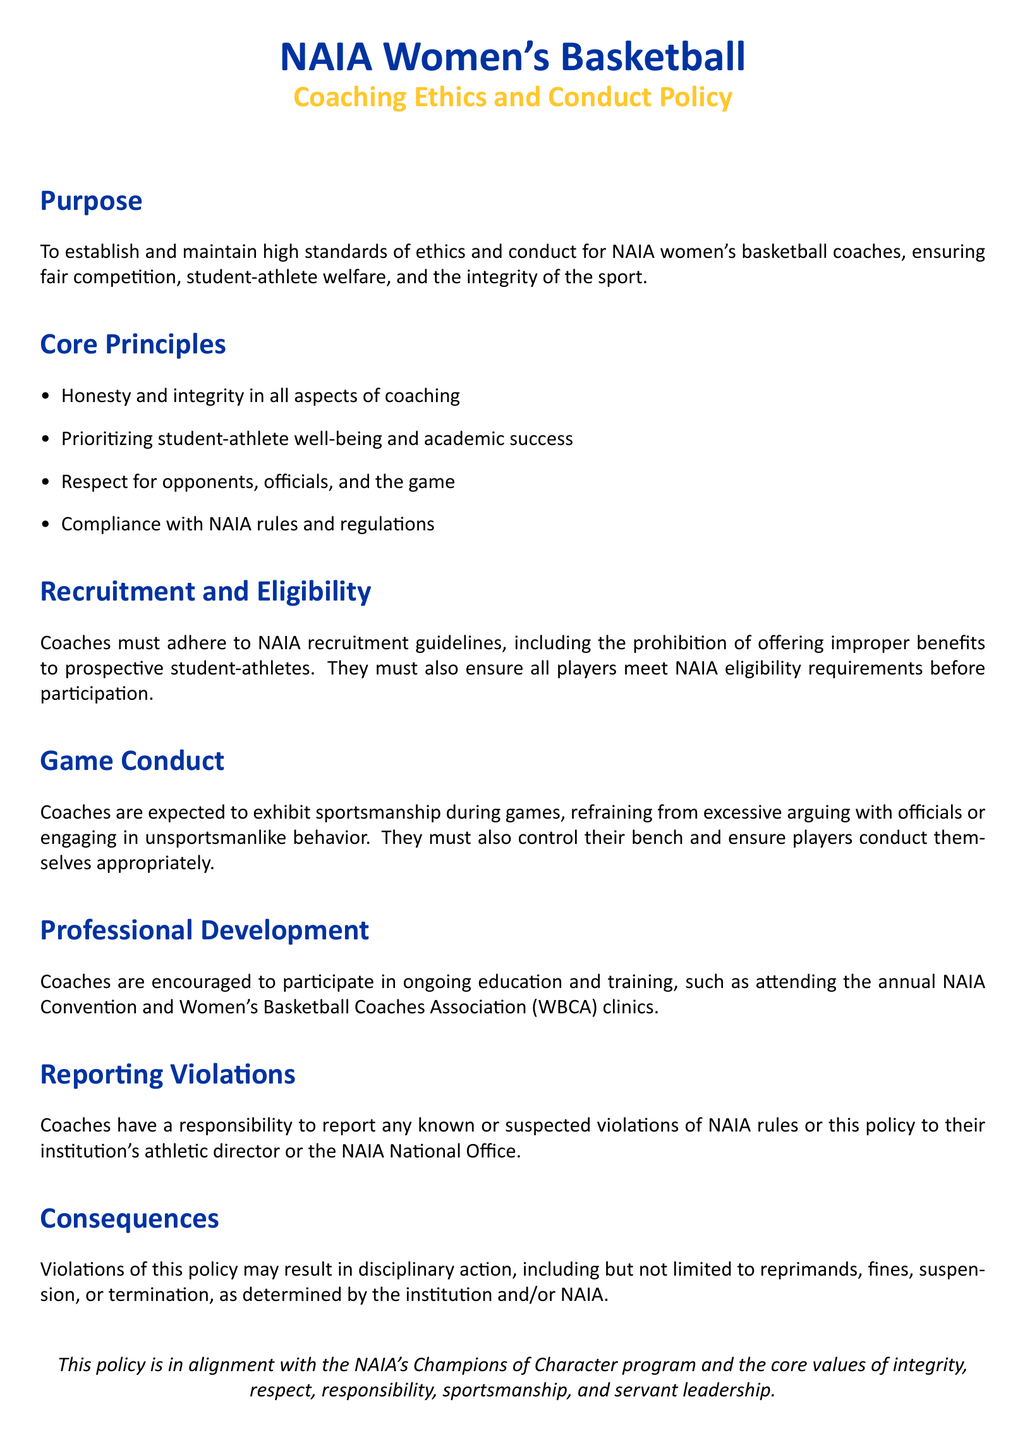What is the purpose of the policy? The purpose is to establish and maintain high standards of ethics and conduct for NAIA women's basketball coaches, ensuring fair competition, student-athlete welfare, and the integrity of the sport.
Answer: To establish and maintain high standards of ethics and conduct What principle emphasizes student-athlete well-being? This principle focuses on prioritizing student-athlete well-being and academic success among other ethical considerations.
Answer: Prioritizing student-athlete well-being and academic success What is prohibited in the recruitment process? The document states that coaches must refrain from offering improper benefits to prospective student-athletes during recruitment.
Answer: Offering improper benefits Who should report known violations? Coaches are responsible for reporting any known or suspected violations to their institution's athletic director or the NAIA National Office.
Answer: Their institution's athletic director or the NAIA National Office What can be a consequence of policy violations? The document mentions disciplinary action which may include reprimands, fines, suspension, or termination upon violations of the policy.
Answer: Reprimands What type of events should coaches attend for professional development? Coaches are encouraged to attend the annual NAIA Convention and Women's Basketball Coaches Association clinics for ongoing education and training.
Answer: NAIA Convention and WBCA clinics 